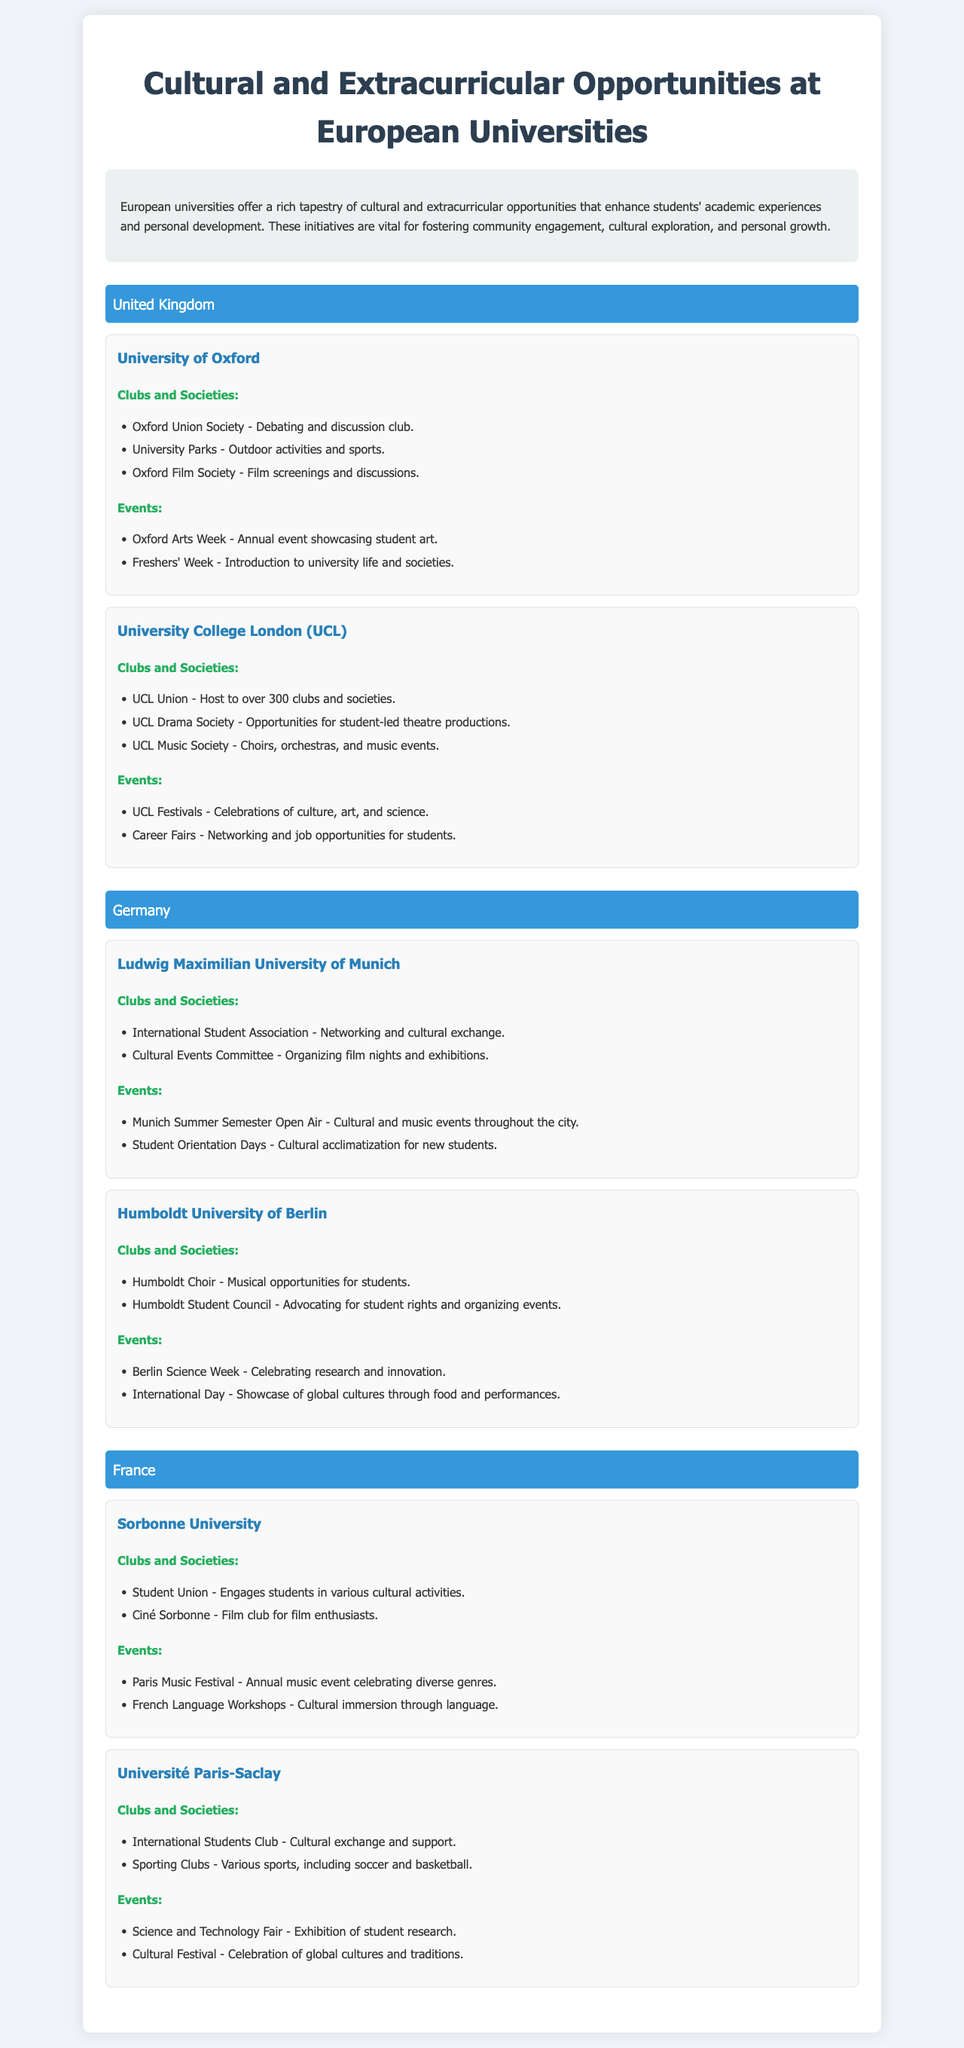What is the name of the debating club at Oxford? The document mentions the Oxford Union Society as the debating and discussion club at the University of Oxford.
Answer: Oxford Union Society How many clubs are hosted by UCL Union? According to the document, UCL Union hosts over 300 clubs and societies for students.
Answer: Over 300 What annual event showcases student art at Oxford? The document states that the Oxford Arts Week is an annual event showcasing student art.
Answer: Oxford Arts Week Which university has the International Student Association? The Ludwig Maximilian University of Munich is mentioned to have the International Student Association for networking and cultural exchange.
Answer: Ludwig Maximilian University of Munich What cultural festival is celebrated at Université Paris-Saclay? The document indicates that a Cultural Festival is celebrated at Université Paris-Saclay, showcasing global cultures and traditions.
Answer: Cultural Festival How many clubs and societies does the University of Oxford have listed? Under clubs and societies at the University of Oxford, three specific clubs are listed in the document.
Answer: Three What type of events are organized by the Cultural Events Committee at Ludwig Maximilian University of Munich? The Cultural Events Committee organizes film nights and exhibitions, as referenced in the document.
Answer: Film nights and exhibitions What opportunity does UCL Drama Society provide? The document states that UCL Drama Society offers opportunities for student-led theatre productions.
Answer: Student-led theatre productions 